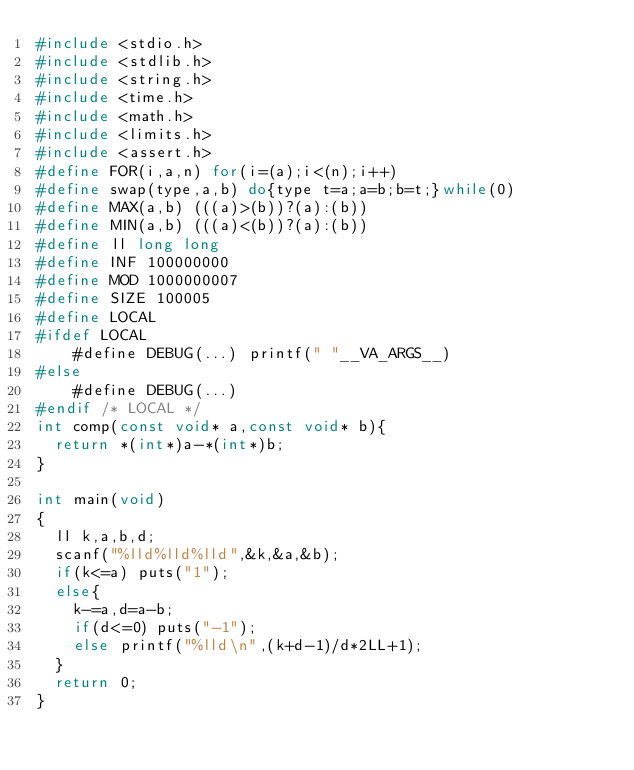<code> <loc_0><loc_0><loc_500><loc_500><_C_>#include <stdio.h>
#include <stdlib.h>
#include <string.h>
#include <time.h>
#include <math.h>
#include <limits.h>
#include <assert.h>
#define FOR(i,a,n) for(i=(a);i<(n);i++)
#define swap(type,a,b) do{type t=a;a=b;b=t;}while(0)
#define MAX(a,b) (((a)>(b))?(a):(b))
#define MIN(a,b) (((a)<(b))?(a):(b))
#define ll long long
#define INF 100000000
#define MOD 1000000007
#define SIZE 100005
#define LOCAL
#ifdef LOCAL
    #define DEBUG(...) printf(" "__VA_ARGS__)
#else
    #define DEBUG(...)
#endif /* LOCAL */
int comp(const void* a,const void* b){
	return *(int*)a-*(int*)b;
}

int main(void)
{
	ll k,a,b,d;
	scanf("%lld%lld%lld",&k,&a,&b);
	if(k<=a) puts("1");
	else{
		k-=a,d=a-b;
		if(d<=0) puts("-1");
		else printf("%lld\n",(k+d-1)/d*2LL+1);
	}
	return 0;
}
    
    
</code> 